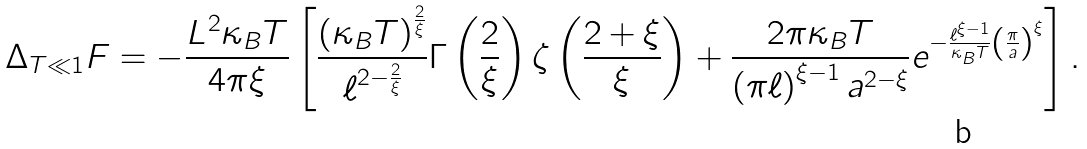<formula> <loc_0><loc_0><loc_500><loc_500>\Delta _ { T \ll 1 } F = - \frac { L ^ { 2 } \kappa _ { B } T } { 4 \pi \xi } \left [ \frac { \left ( \kappa _ { B } T \right ) ^ { \frac { 2 } { \xi } } } { \ell ^ { 2 - \frac { 2 } { \xi } } } \Gamma \left ( \frac { 2 } { \xi } \right ) \zeta \left ( \frac { 2 + \xi } { \xi } \right ) + \frac { 2 \pi \kappa _ { B } T } { \left ( \pi \ell \right ) ^ { \xi - 1 } a ^ { 2 - \xi } } e ^ { - \frac { \ell ^ { \xi - 1 } } { \kappa _ { B } T } \left ( \frac { \pi } { a } \right ) ^ { \xi } } \right ] .</formula> 